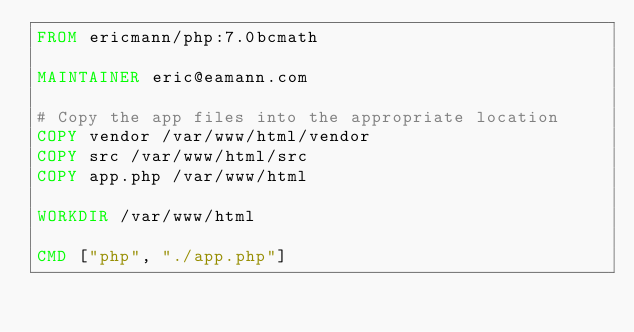<code> <loc_0><loc_0><loc_500><loc_500><_Dockerfile_>FROM ericmann/php:7.0bcmath

MAINTAINER eric@eamann.com

# Copy the app files into the appropriate location
COPY vendor /var/www/html/vendor
COPY src /var/www/html/src
COPY app.php /var/www/html

WORKDIR /var/www/html

CMD ["php", "./app.php"]</code> 